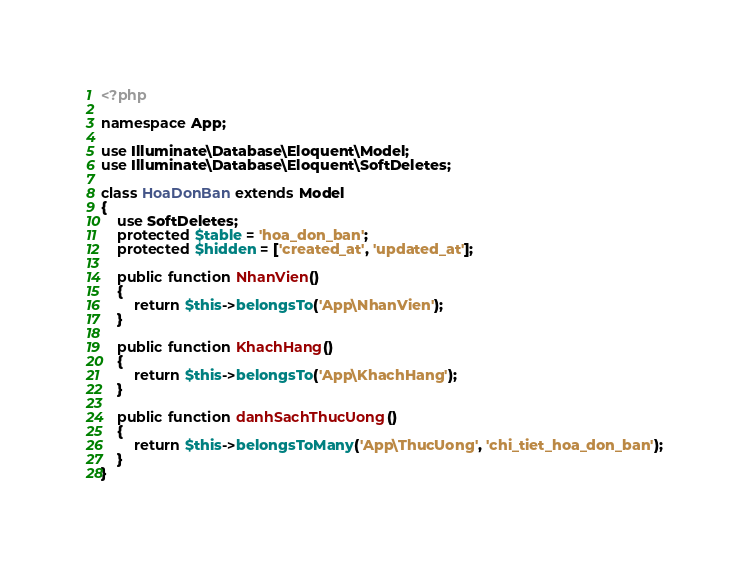Convert code to text. <code><loc_0><loc_0><loc_500><loc_500><_PHP_><?php

namespace App;

use Illuminate\Database\Eloquent\Model;
use Illuminate\Database\Eloquent\SoftDeletes;

class HoaDonBan extends Model
{
    use SoftDeletes;
    protected $table = 'hoa_don_ban';
    protected $hidden = ['created_at', 'updated_at'];

    public function NhanVien()
    {
        return $this->belongsTo('App\NhanVien');
    }
    
    public function KhachHang()
    {
        return $this->belongsTo('App\KhachHang');
    }

    public function danhSachThucUong()
    {
        return $this->belongsToMany('App\ThucUong', 'chi_tiet_hoa_don_ban');
    }
}
</code> 